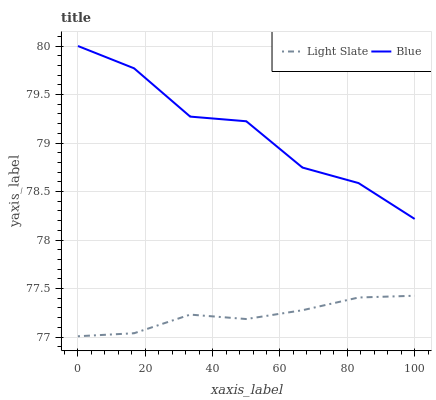Does Light Slate have the minimum area under the curve?
Answer yes or no. Yes. Does Blue have the maximum area under the curve?
Answer yes or no. Yes. Does Blue have the minimum area under the curve?
Answer yes or no. No. Is Light Slate the smoothest?
Answer yes or no. Yes. Is Blue the roughest?
Answer yes or no. Yes. Is Blue the smoothest?
Answer yes or no. No. Does Light Slate have the lowest value?
Answer yes or no. Yes. Does Blue have the lowest value?
Answer yes or no. No. Does Blue have the highest value?
Answer yes or no. Yes. Is Light Slate less than Blue?
Answer yes or no. Yes. Is Blue greater than Light Slate?
Answer yes or no. Yes. Does Light Slate intersect Blue?
Answer yes or no. No. 